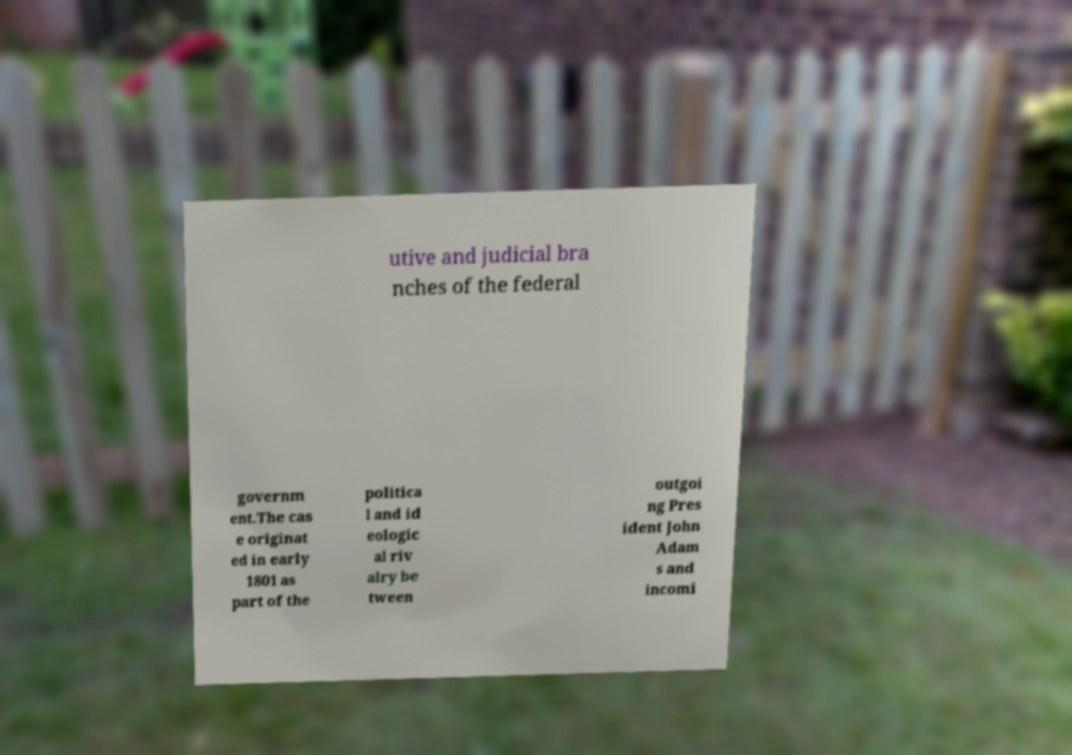Can you read and provide the text displayed in the image?This photo seems to have some interesting text. Can you extract and type it out for me? utive and judicial bra nches of the federal governm ent.The cas e originat ed in early 1801 as part of the politica l and id eologic al riv alry be tween outgoi ng Pres ident John Adam s and incomi 